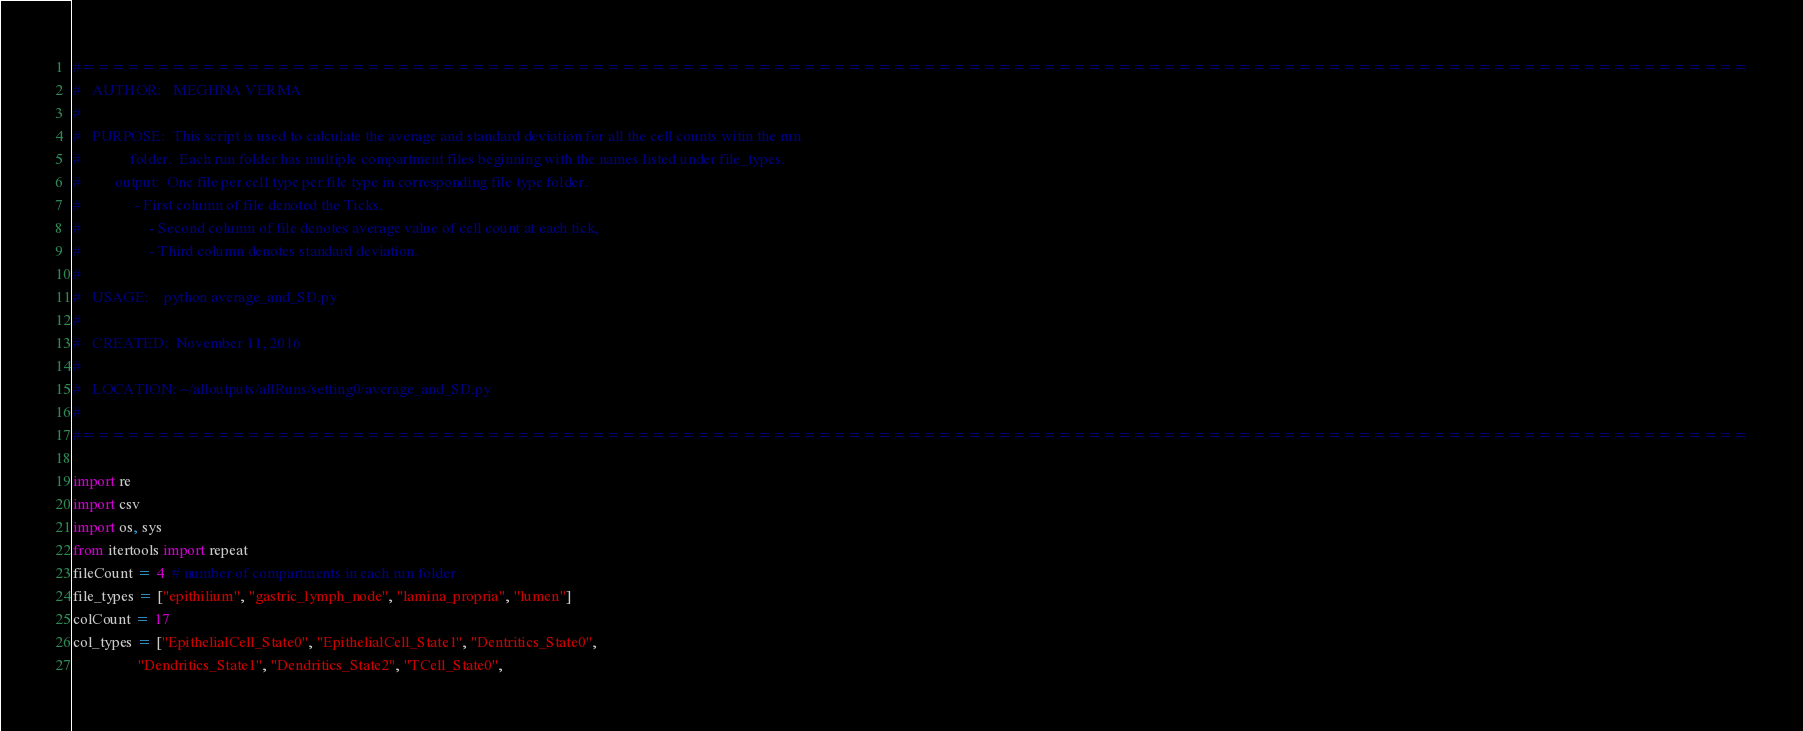Convert code to text. <code><loc_0><loc_0><loc_500><loc_500><_Python_>#===============================================================================================================
#   AUTHOR:   MEGHNA VERMA
#
#   PURPOSE:  This script is used to calculate the average and standard deviation for all the cell counts witin the run
#             folder.  Each run folder has multiple compartment files beginning with the names listed under file_types. 
#	      output:  One file per cell type per file type in corresponding file type folder.
#		       - First column of file denoted the Ticks. 
#    		       - Second column of file denotes average value of cell count at each tick, 
#    		       - Third column denotes standard deviation.
#    	     
#   USAGE:    python average_and_SD.py 
#	     
#   CREATED:  November 11, 2016
#   
#   LOCATION: ~/alloutputs/allRuns/setting0/average_and_SD.py
#
#===============================================================================================================

import re
import csv
import os, sys
from itertools import repeat
fileCount = 4  # number of compartments in each run folder
file_types = ["epithilium", "gastric_lymph_node", "lamina_propria", "lumen"]
colCount = 17
col_types = ["EpithelialCell_State0", "EpithelialCell_State1", "Dentritics_State0", 
                 "Dendritics_State1", "Dendritics_State2", "TCell_State0",</code> 